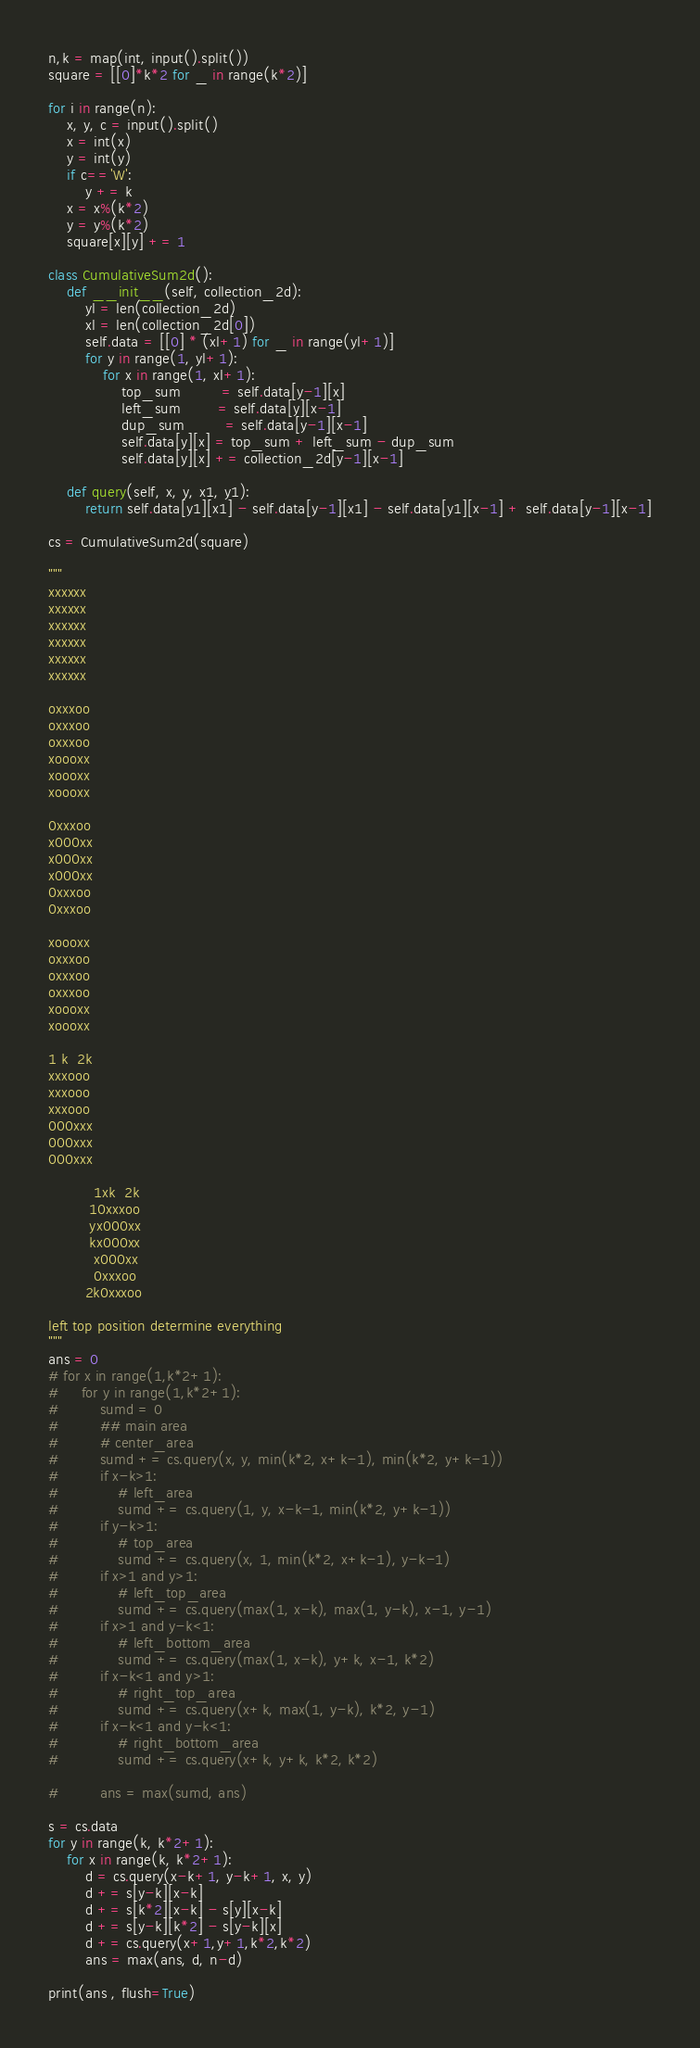<code> <loc_0><loc_0><loc_500><loc_500><_Python_>n,k = map(int, input().split())
square = [[0]*k*2 for _ in range(k*2)]

for i in range(n):
    x, y, c = input().split()
    x = int(x)
    y = int(y)
    if c=='W':
        y += k
    x = x%(k*2)
    y = y%(k*2)
    square[x][y] += 1

class CumulativeSum2d():
    def __init__(self, collection_2d):
        yl = len(collection_2d)
        xl = len(collection_2d[0])
        self.data = [[0] * (xl+1) for _ in range(yl+1)]
        for y in range(1, yl+1):
            for x in range(1, xl+1):
                top_sum         = self.data[y-1][x]
                left_sum        = self.data[y][x-1]
                dup_sum         = self.data[y-1][x-1]
                self.data[y][x] = top_sum + left_sum - dup_sum
                self.data[y][x] += collection_2d[y-1][x-1]

    def query(self, x, y, x1, y1):
        return self.data[y1][x1] - self.data[y-1][x1] - self.data[y1][x-1] + self.data[y-1][x-1]

cs = CumulativeSum2d(square)

"""
xxxxxx
xxxxxx
xxxxxx
xxxxxx
xxxxxx
xxxxxx

oxxxoo
oxxxoo
oxxxoo
xoooxx
xoooxx
xoooxx

0xxxoo
x000xx
x000xx
x000xx
0xxxoo
0xxxoo

xoooxx
oxxxoo
oxxxoo
oxxxoo
xoooxx
xoooxx

1 k  2k
xxxooo
xxxooo
xxxooo
000xxx
000xxx
000xxx

          1xk  2k
         10xxxoo
         yx000xx
         kx000xx
          x000xx
          0xxxoo
        2k0xxxoo

left top position determine everything
"""
ans = 0
# for x in range(1,k*2+1):
#     for y in range(1,k*2+1):
#         sumd = 0
#         ## main area
#         # center_area
#         sumd += cs.query(x, y, min(k*2, x+k-1), min(k*2, y+k-1))
#         if x-k>1:
#             # left_area
#             sumd += cs.query(1, y, x-k-1, min(k*2, y+k-1))
#         if y-k>1:
#             # top_area
#             sumd += cs.query(x, 1, min(k*2, x+k-1), y-k-1)
#         if x>1 and y>1:
#             # left_top_area
#             sumd += cs.query(max(1, x-k), max(1, y-k), x-1, y-1)
#         if x>1 and y-k<1:
#             # left_bottom_area
#             sumd += cs.query(max(1, x-k), y+k, x-1, k*2)
#         if x-k<1 and y>1:
#             # right_top_area
#             sumd += cs.query(x+k, max(1, y-k), k*2, y-1)
#         if x-k<1 and y-k<1:
#             # right_bottom_area
#             sumd += cs.query(x+k, y+k, k*2, k*2)

#         ans = max(sumd, ans)

s = cs.data
for y in range(k, k*2+1):
    for x in range(k, k*2+1):
        d = cs.query(x-k+1, y-k+1, x, y)
        d += s[y-k][x-k]
        d += s[k*2][x-k] - s[y][x-k]
        d += s[y-k][k*2] - s[y-k][x]
        d += cs.query(x+1,y+1,k*2,k*2)
        ans = max(ans, d, n-d)

print(ans , flush=True)
</code> 